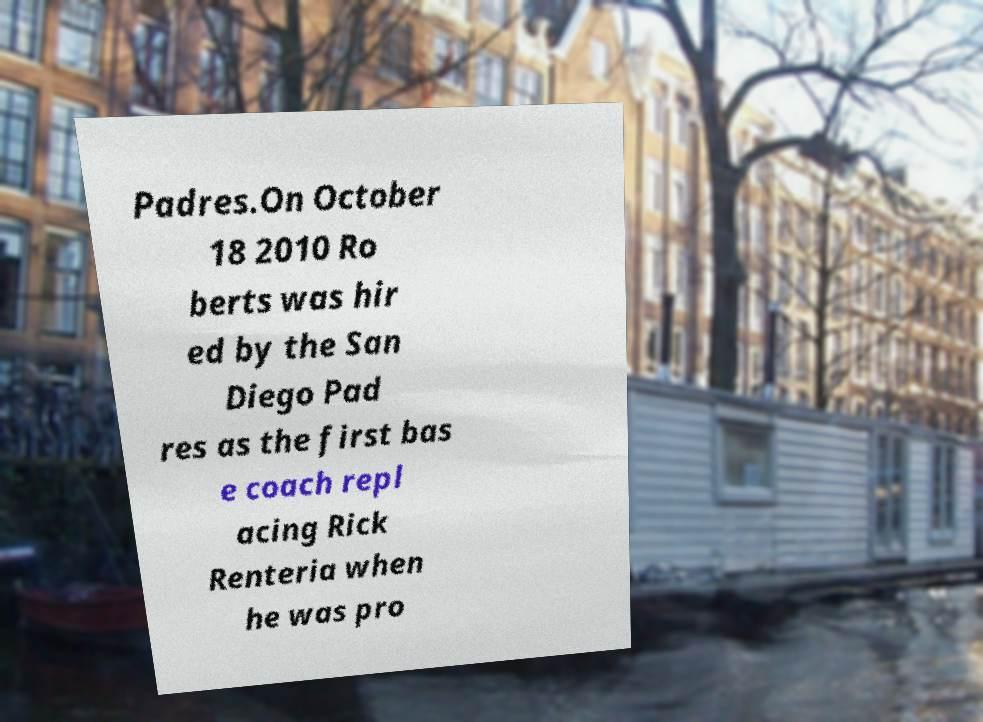Can you accurately transcribe the text from the provided image for me? Padres.On October 18 2010 Ro berts was hir ed by the San Diego Pad res as the first bas e coach repl acing Rick Renteria when he was pro 